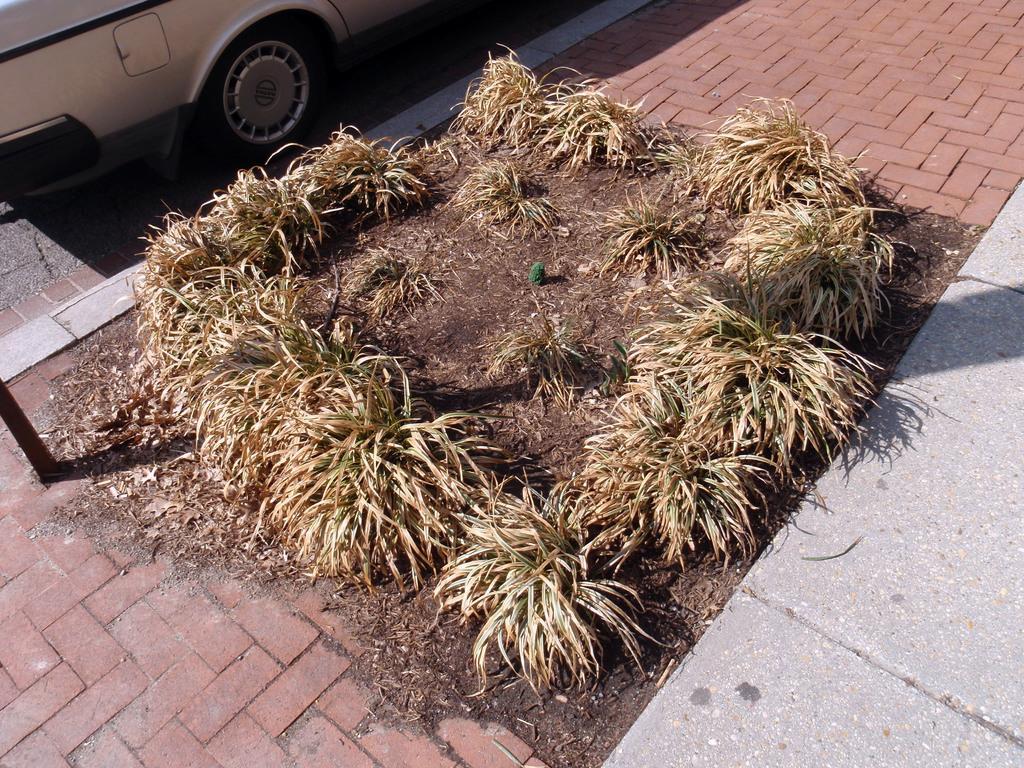Could you give a brief overview of what you see in this image? In this image we can see some plants on the ground. We can also see a pole and a car parked aside. 